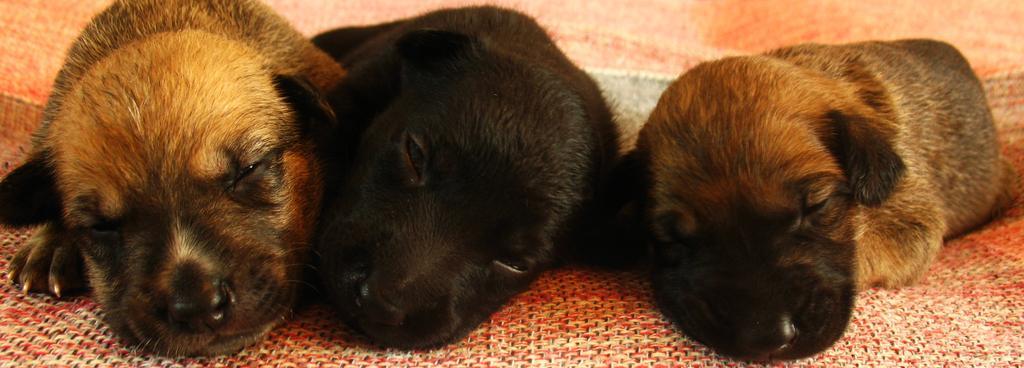Could you give a brief overview of what you see in this image? In this image I can see two brown and one black colour puppy. 